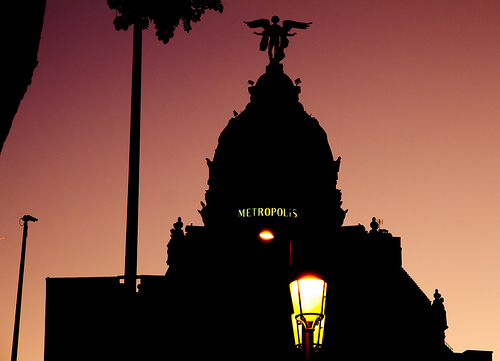<image>
Is there a statue above the metropolis? Yes. The statue is positioned above the metropolis in the vertical space, higher up in the scene. 